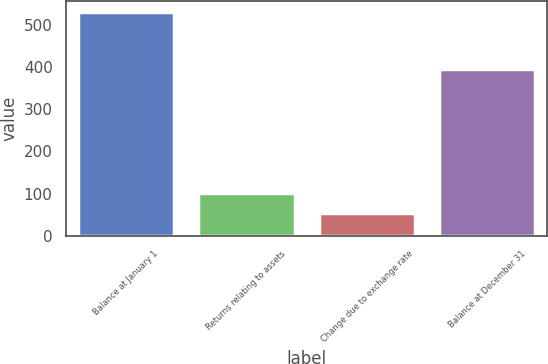Convert chart. <chart><loc_0><loc_0><loc_500><loc_500><bar_chart><fcel>Balance at January 1<fcel>Returns relating to assets<fcel>Change due to exchange rate<fcel>Balance at December 31<nl><fcel>530<fcel>100.7<fcel>53<fcel>396<nl></chart> 